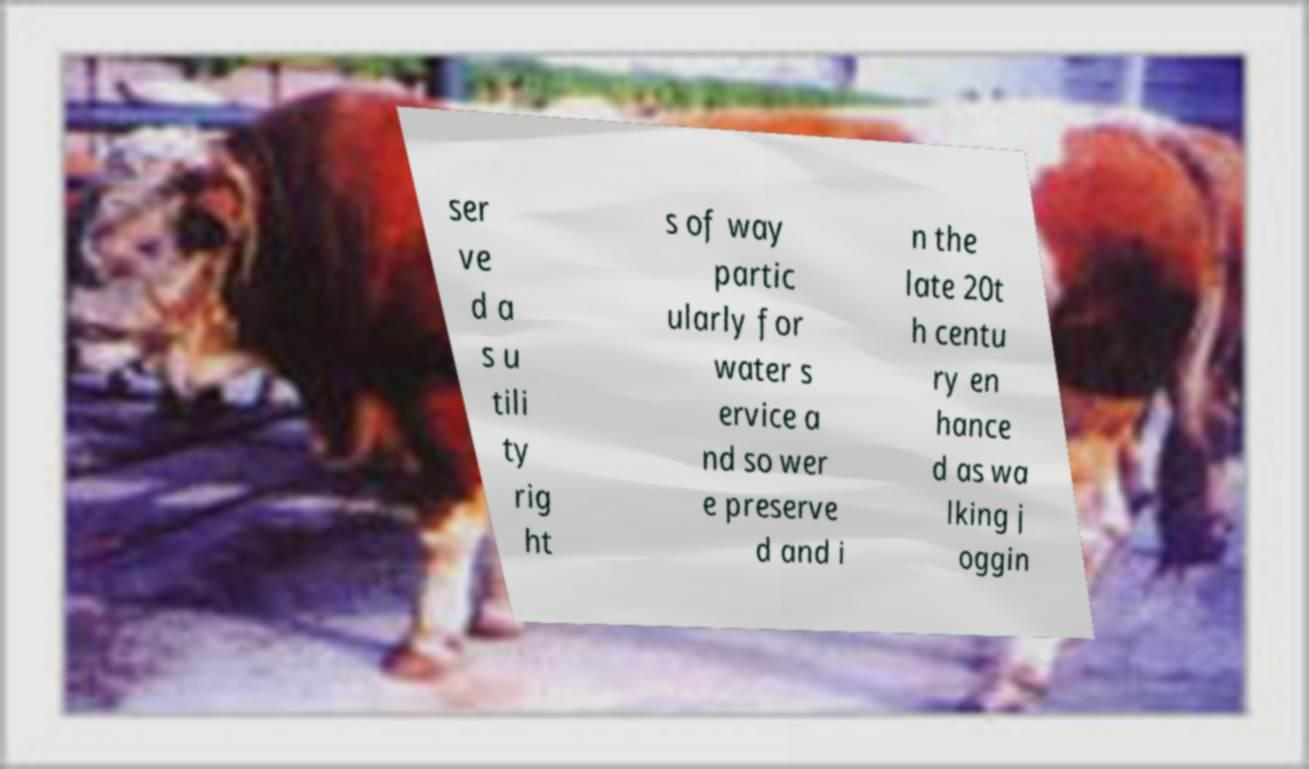Can you read and provide the text displayed in the image?This photo seems to have some interesting text. Can you extract and type it out for me? ser ve d a s u tili ty rig ht s of way partic ularly for water s ervice a nd so wer e preserve d and i n the late 20t h centu ry en hance d as wa lking j oggin 